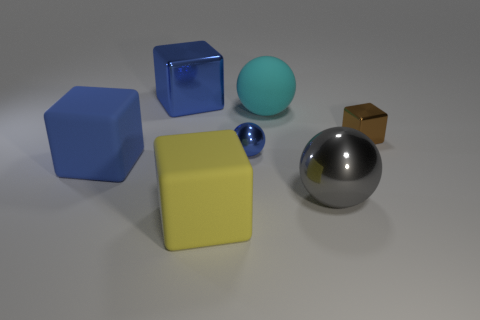How many other objects are there of the same size as the gray object?
Offer a terse response. 4. Is the color of the small block the same as the big cube that is on the left side of the blue metallic cube?
Ensure brevity in your answer.  No. What number of blocks are either tiny blue metal objects or big purple matte things?
Give a very brief answer. 0. Is there any other thing that is the same color as the big shiny ball?
Offer a very short reply. No. There is a brown cube right of the big rubber cube on the left side of the big yellow matte cube; what is it made of?
Your answer should be very brief. Metal. Is the yellow block made of the same material as the big blue block behind the tiny brown metallic object?
Ensure brevity in your answer.  No. How many objects are either rubber cubes that are in front of the gray shiny ball or big gray rubber things?
Give a very brief answer. 1. Is there a big metal ball that has the same color as the matte sphere?
Your answer should be very brief. No. There is a brown thing; does it have the same shape as the shiny object that is behind the big cyan rubber sphere?
Provide a short and direct response. Yes. What number of spheres are on the right side of the cyan rubber object and on the left side of the large matte ball?
Provide a succinct answer. 0. 